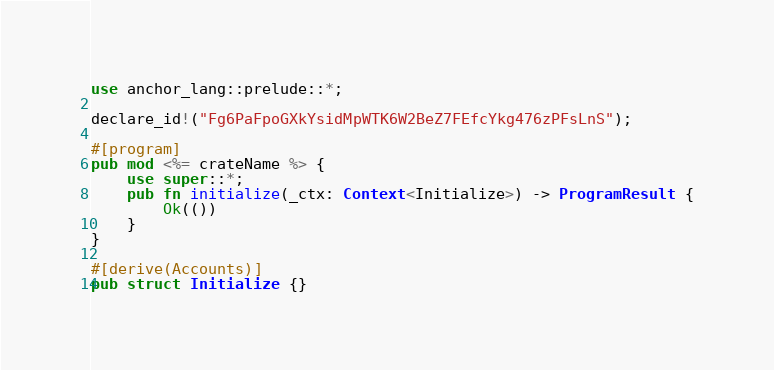<code> <loc_0><loc_0><loc_500><loc_500><_Rust_>use anchor_lang::prelude::*;

declare_id!("Fg6PaFpoGXkYsidMpWTK6W2BeZ7FEfcYkg476zPFsLnS");

#[program]
pub mod <%= crateName %> {
    use super::*;
    pub fn initialize(_ctx: Context<Initialize>) -> ProgramResult {
        Ok(())
    }
}

#[derive(Accounts)]
pub struct Initialize {}
</code> 